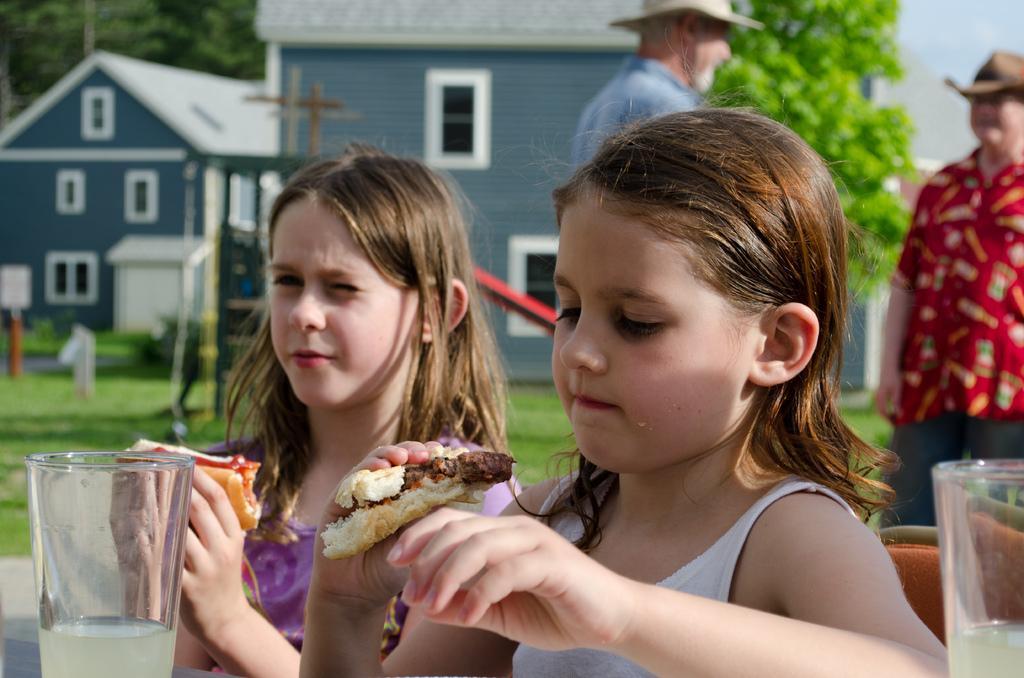How would you summarize this image in a sentence or two? In this image in the foreground there are two girls who are holding food item, and on the left side there is one glass. In the background there are two persons who are standing, and they are wearing hats and also in the background there are some houses and trees. On the right side there is one glass, in the center there is a grass and some poles. 